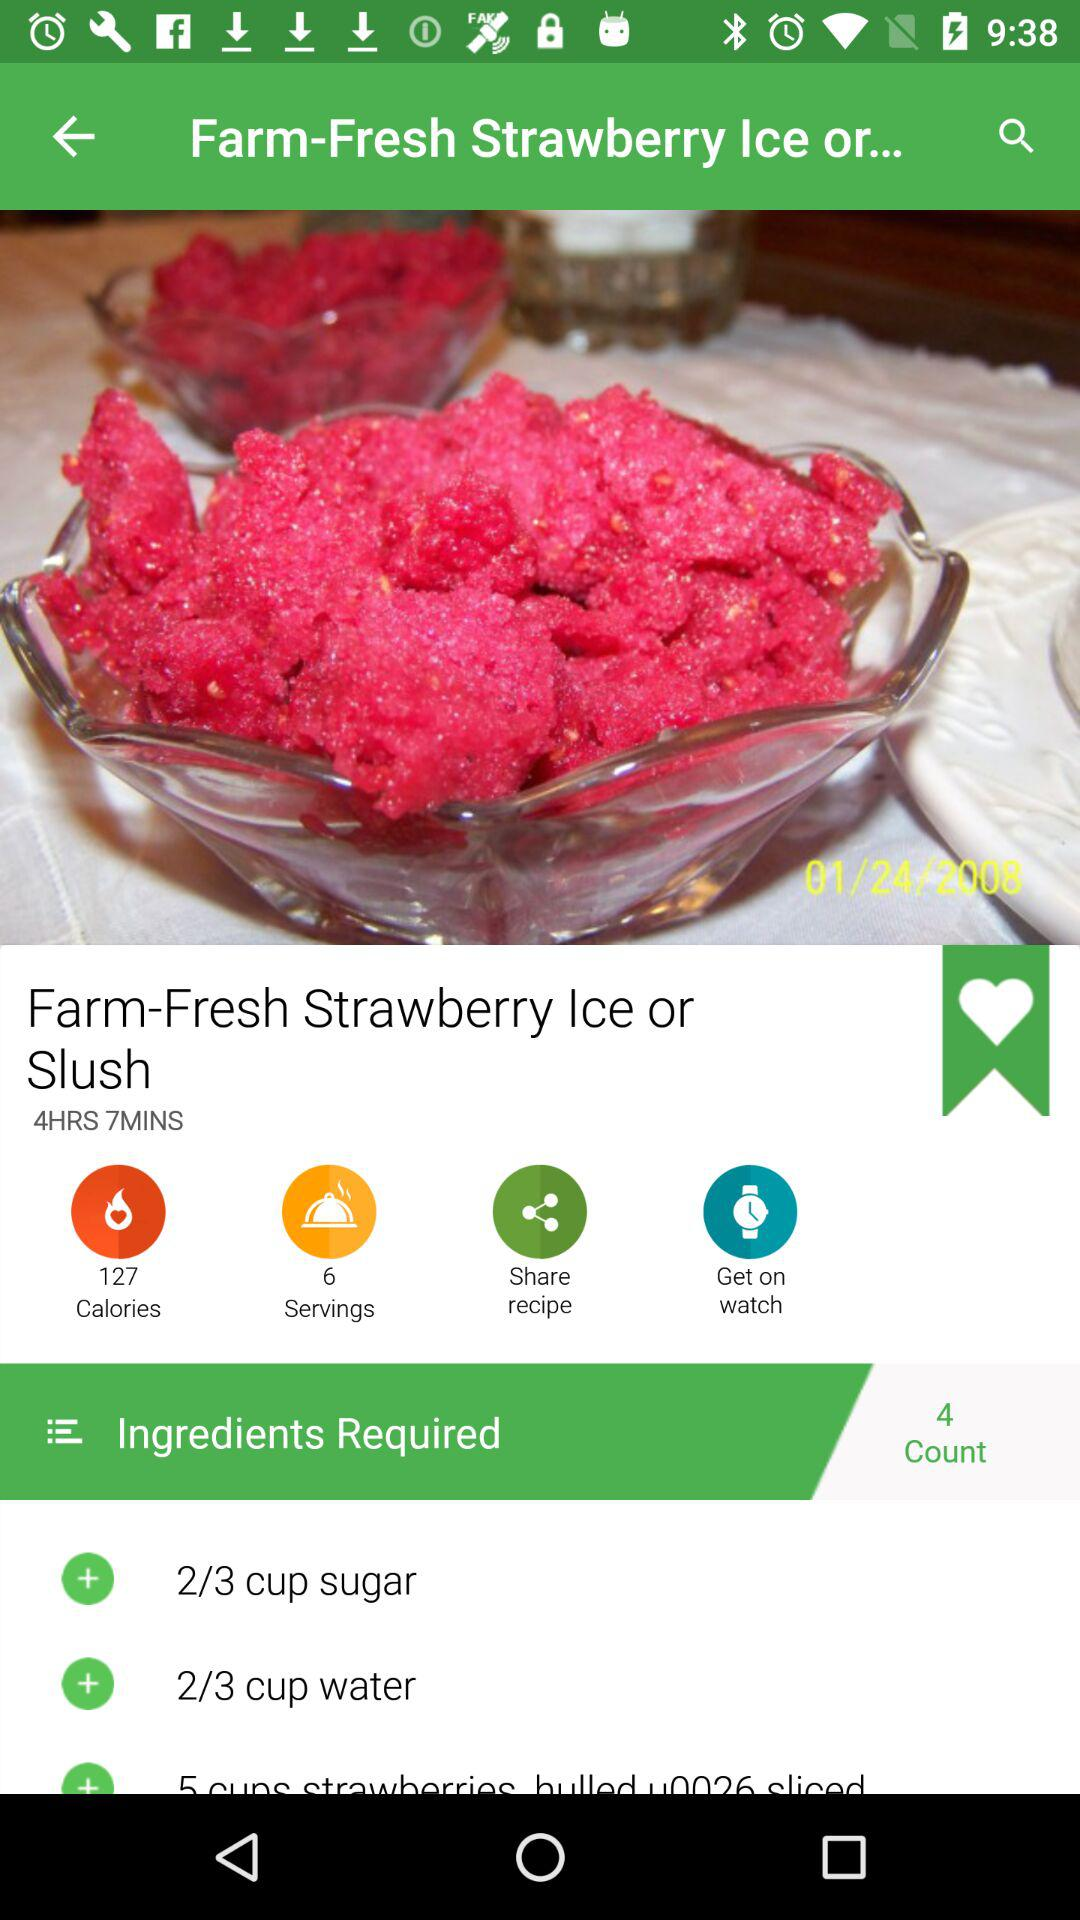Which ingredients are required? The required ingredients are 2/3 cup sugar and 2/3 cup water. 